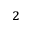Convert formula to latex. <formula><loc_0><loc_0><loc_500><loc_500>^ { 2 }</formula> 